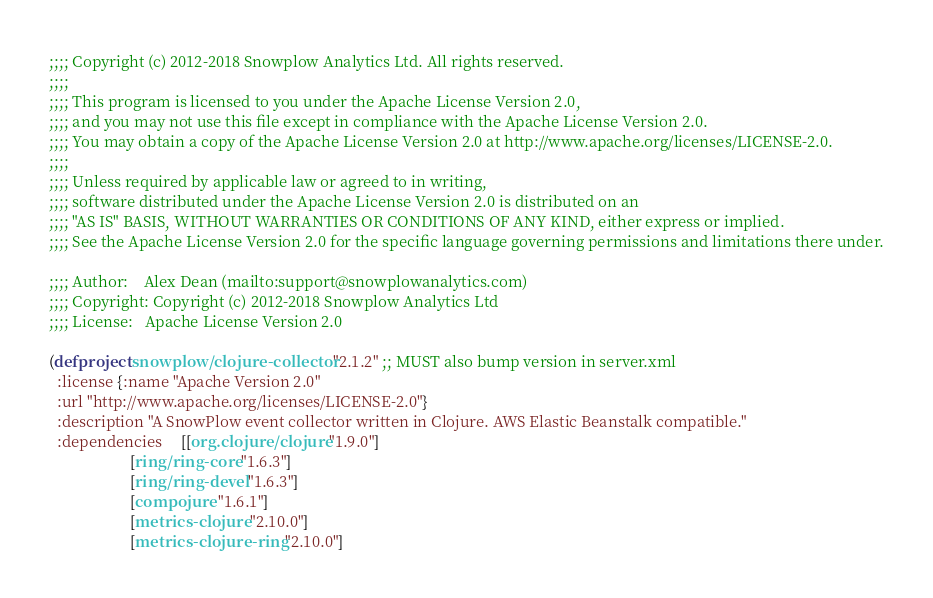Convert code to text. <code><loc_0><loc_0><loc_500><loc_500><_Clojure_>;;;; Copyright (c) 2012-2018 Snowplow Analytics Ltd. All rights reserved.
;;;;
;;;; This program is licensed to you under the Apache License Version 2.0,
;;;; and you may not use this file except in compliance with the Apache License Version 2.0.
;;;; You may obtain a copy of the Apache License Version 2.0 at http://www.apache.org/licenses/LICENSE-2.0.
;;;;
;;;; Unless required by applicable law or agreed to in writing,
;;;; software distributed under the Apache License Version 2.0 is distributed on an
;;;; "AS IS" BASIS, WITHOUT WARRANTIES OR CONDITIONS OF ANY KIND, either express or implied.
;;;; See the Apache License Version 2.0 for the specific language governing permissions and limitations there under.

;;;; Author:    Alex Dean (mailto:support@snowplowanalytics.com)
;;;; Copyright: Copyright (c) 2012-2018 Snowplow Analytics Ltd
;;;; License:   Apache License Version 2.0

(defproject snowplow/clojure-collector "2.1.2" ;; MUST also bump version in server.xml
  :license {:name "Apache Version 2.0"
  :url "http://www.apache.org/licenses/LICENSE-2.0"}
  :description "A SnowPlow event collector written in Clojure. AWS Elastic Beanstalk compatible."
  :dependencies     [[org.clojure/clojure "1.9.0"]
                     [ring/ring-core "1.6.3"]
                     [ring/ring-devel "1.6.3"]
                     [compojure "1.6.1"]
                     [metrics-clojure "2.10.0"]
                     [metrics-clojure-ring "2.10.0"]</code> 